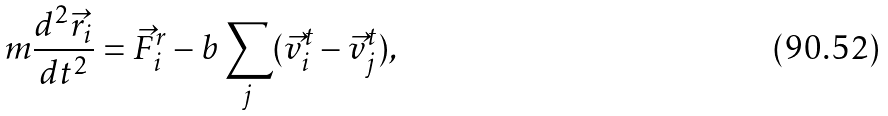<formula> <loc_0><loc_0><loc_500><loc_500>m \frac { d ^ { 2 } { \vec { r } } _ { i } } { d t ^ { 2 } } = { \vec { F } } ^ { r } _ { i } - b \sum _ { j } ( { \vec { v } } ^ { t } _ { i } - { \vec { v } } ^ { t } _ { j } ) ,</formula> 